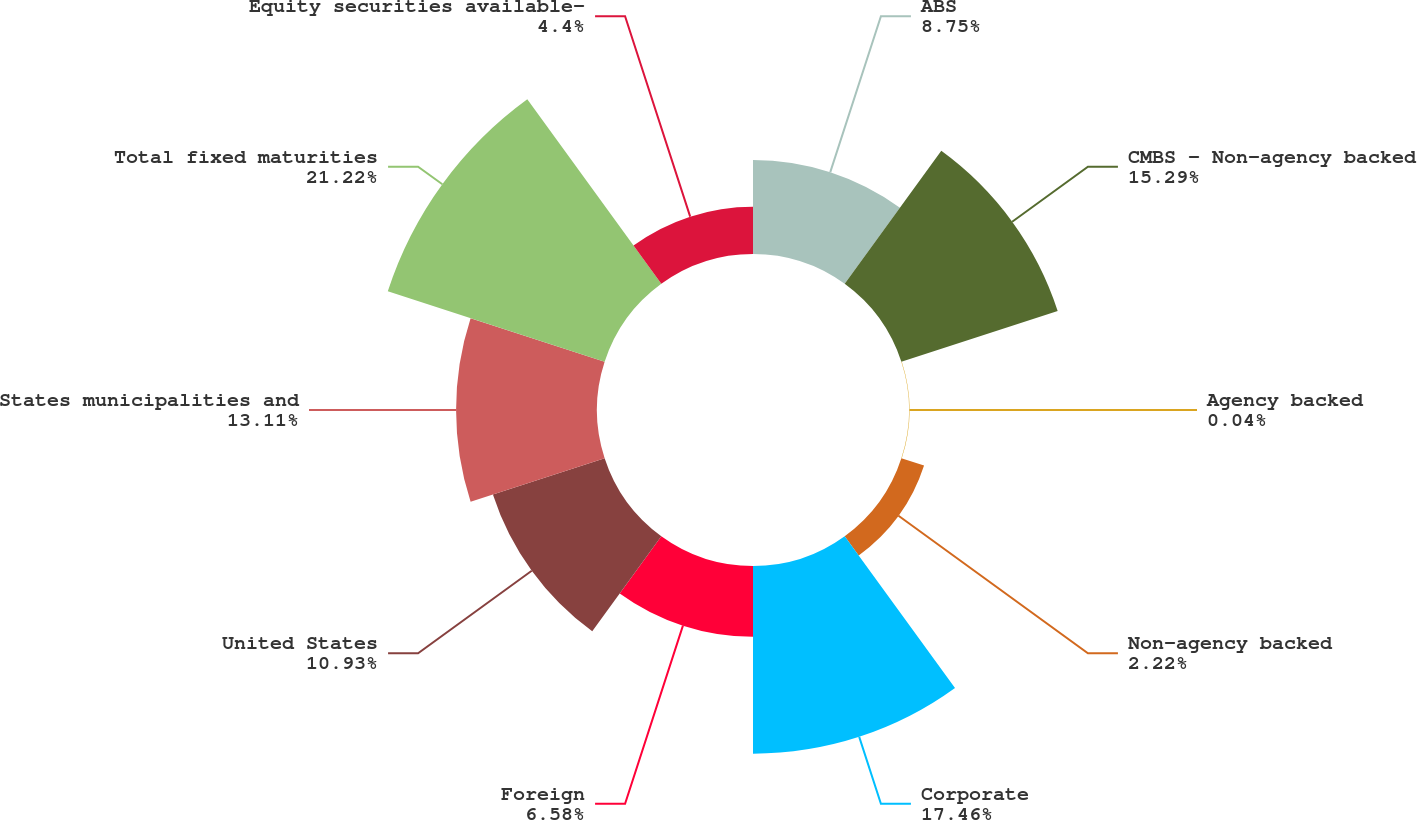Convert chart. <chart><loc_0><loc_0><loc_500><loc_500><pie_chart><fcel>ABS<fcel>CMBS - Non-agency backed<fcel>Agency backed<fcel>Non-agency backed<fcel>Corporate<fcel>Foreign<fcel>United States<fcel>States municipalities and<fcel>Total fixed maturities<fcel>Equity securities available-<nl><fcel>8.75%<fcel>15.29%<fcel>0.04%<fcel>2.22%<fcel>17.46%<fcel>6.58%<fcel>10.93%<fcel>13.11%<fcel>21.21%<fcel>4.4%<nl></chart> 